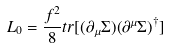<formula> <loc_0><loc_0><loc_500><loc_500>L _ { 0 } = \frac { f ^ { 2 } } { 8 } t r [ ( \partial _ { \mu } \Sigma ) ( \partial ^ { \mu } \Sigma ) ^ { \dag } ]</formula> 